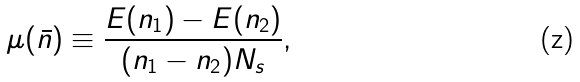Convert formula to latex. <formula><loc_0><loc_0><loc_500><loc_500>\mu ( \bar { n } ) \equiv \frac { E ( n _ { 1 } ) - E ( n _ { 2 } ) } { ( n _ { 1 } - n _ { 2 } ) N _ { s } } ,</formula> 